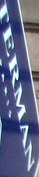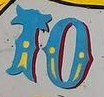What text is displayed in these images sequentially, separated by a semicolon? TERMAN; TO 